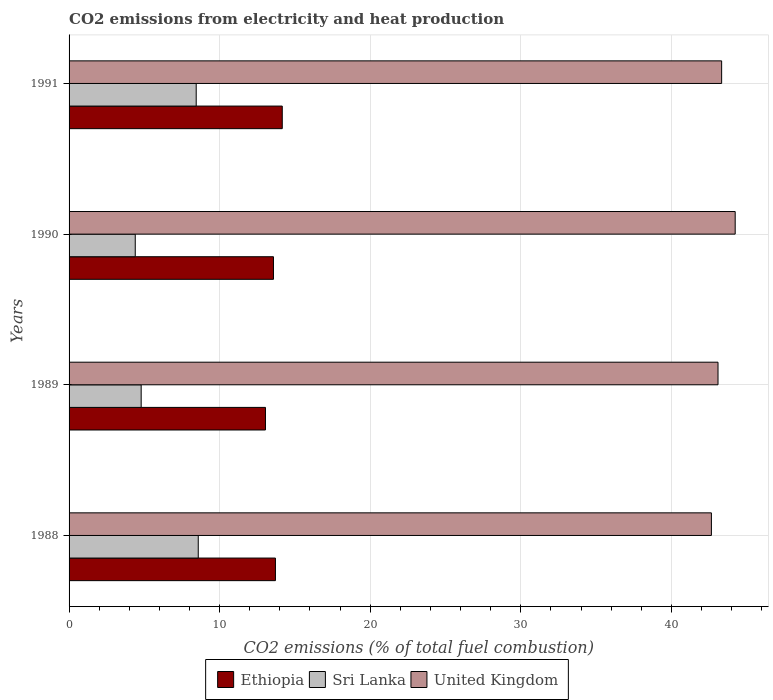How many groups of bars are there?
Offer a terse response. 4. How many bars are there on the 1st tick from the bottom?
Give a very brief answer. 3. In how many cases, is the number of bars for a given year not equal to the number of legend labels?
Ensure brevity in your answer.  0. What is the amount of CO2 emitted in Sri Lanka in 1990?
Your response must be concise. 4.4. Across all years, what is the maximum amount of CO2 emitted in Sri Lanka?
Your response must be concise. 8.58. Across all years, what is the minimum amount of CO2 emitted in United Kingdom?
Keep it short and to the point. 42.66. In which year was the amount of CO2 emitted in Sri Lanka maximum?
Your response must be concise. 1988. What is the total amount of CO2 emitted in United Kingdom in the graph?
Provide a short and direct response. 173.34. What is the difference between the amount of CO2 emitted in Sri Lanka in 1989 and that in 1991?
Make the answer very short. -3.65. What is the difference between the amount of CO2 emitted in Sri Lanka in 1991 and the amount of CO2 emitted in United Kingdom in 1988?
Make the answer very short. -34.22. What is the average amount of CO2 emitted in United Kingdom per year?
Offer a terse response. 43.34. In the year 1991, what is the difference between the amount of CO2 emitted in Ethiopia and amount of CO2 emitted in United Kingdom?
Make the answer very short. -29.18. What is the ratio of the amount of CO2 emitted in United Kingdom in 1988 to that in 1991?
Provide a succinct answer. 0.98. Is the difference between the amount of CO2 emitted in Ethiopia in 1988 and 1989 greater than the difference between the amount of CO2 emitted in United Kingdom in 1988 and 1989?
Your answer should be compact. Yes. What is the difference between the highest and the second highest amount of CO2 emitted in Sri Lanka?
Give a very brief answer. 0.14. What is the difference between the highest and the lowest amount of CO2 emitted in Sri Lanka?
Your answer should be compact. 4.18. Is the sum of the amount of CO2 emitted in United Kingdom in 1989 and 1991 greater than the maximum amount of CO2 emitted in Sri Lanka across all years?
Provide a short and direct response. Yes. What does the 2nd bar from the top in 1988 represents?
Ensure brevity in your answer.  Sri Lanka. What does the 3rd bar from the bottom in 1989 represents?
Offer a very short reply. United Kingdom. Is it the case that in every year, the sum of the amount of CO2 emitted in United Kingdom and amount of CO2 emitted in Sri Lanka is greater than the amount of CO2 emitted in Ethiopia?
Ensure brevity in your answer.  Yes. Are all the bars in the graph horizontal?
Provide a succinct answer. Yes. How many years are there in the graph?
Offer a very short reply. 4. Does the graph contain any zero values?
Offer a terse response. No. Where does the legend appear in the graph?
Provide a succinct answer. Bottom center. How are the legend labels stacked?
Offer a very short reply. Horizontal. What is the title of the graph?
Provide a short and direct response. CO2 emissions from electricity and heat production. Does "Brunei Darussalam" appear as one of the legend labels in the graph?
Provide a short and direct response. No. What is the label or title of the X-axis?
Provide a succinct answer. CO2 emissions (% of total fuel combustion). What is the label or title of the Y-axis?
Your answer should be compact. Years. What is the CO2 emissions (% of total fuel combustion) in Ethiopia in 1988?
Make the answer very short. 13.71. What is the CO2 emissions (% of total fuel combustion) of Sri Lanka in 1988?
Provide a succinct answer. 8.58. What is the CO2 emissions (% of total fuel combustion) in United Kingdom in 1988?
Offer a terse response. 42.66. What is the CO2 emissions (% of total fuel combustion) in Ethiopia in 1989?
Your answer should be very brief. 13.04. What is the CO2 emissions (% of total fuel combustion) in Sri Lanka in 1989?
Make the answer very short. 4.79. What is the CO2 emissions (% of total fuel combustion) in United Kingdom in 1989?
Your response must be concise. 43.1. What is the CO2 emissions (% of total fuel combustion) of Ethiopia in 1990?
Make the answer very short. 13.57. What is the CO2 emissions (% of total fuel combustion) of Sri Lanka in 1990?
Your answer should be compact. 4.4. What is the CO2 emissions (% of total fuel combustion) in United Kingdom in 1990?
Ensure brevity in your answer.  44.24. What is the CO2 emissions (% of total fuel combustion) in Ethiopia in 1991?
Your response must be concise. 14.16. What is the CO2 emissions (% of total fuel combustion) in Sri Lanka in 1991?
Ensure brevity in your answer.  8.44. What is the CO2 emissions (% of total fuel combustion) of United Kingdom in 1991?
Offer a very short reply. 43.34. Across all years, what is the maximum CO2 emissions (% of total fuel combustion) of Ethiopia?
Make the answer very short. 14.16. Across all years, what is the maximum CO2 emissions (% of total fuel combustion) in Sri Lanka?
Keep it short and to the point. 8.58. Across all years, what is the maximum CO2 emissions (% of total fuel combustion) in United Kingdom?
Your response must be concise. 44.24. Across all years, what is the minimum CO2 emissions (% of total fuel combustion) in Ethiopia?
Ensure brevity in your answer.  13.04. Across all years, what is the minimum CO2 emissions (% of total fuel combustion) of Sri Lanka?
Ensure brevity in your answer.  4.4. Across all years, what is the minimum CO2 emissions (% of total fuel combustion) of United Kingdom?
Your response must be concise. 42.66. What is the total CO2 emissions (% of total fuel combustion) in Ethiopia in the graph?
Offer a terse response. 54.48. What is the total CO2 emissions (% of total fuel combustion) in Sri Lanka in the graph?
Give a very brief answer. 26.21. What is the total CO2 emissions (% of total fuel combustion) of United Kingdom in the graph?
Make the answer very short. 173.34. What is the difference between the CO2 emissions (% of total fuel combustion) of Ethiopia in 1988 and that in 1989?
Ensure brevity in your answer.  0.66. What is the difference between the CO2 emissions (% of total fuel combustion) of Sri Lanka in 1988 and that in 1989?
Provide a short and direct response. 3.79. What is the difference between the CO2 emissions (% of total fuel combustion) in United Kingdom in 1988 and that in 1989?
Offer a terse response. -0.44. What is the difference between the CO2 emissions (% of total fuel combustion) in Ethiopia in 1988 and that in 1990?
Keep it short and to the point. 0.13. What is the difference between the CO2 emissions (% of total fuel combustion) of Sri Lanka in 1988 and that in 1990?
Your answer should be very brief. 4.18. What is the difference between the CO2 emissions (% of total fuel combustion) of United Kingdom in 1988 and that in 1990?
Your response must be concise. -1.58. What is the difference between the CO2 emissions (% of total fuel combustion) in Ethiopia in 1988 and that in 1991?
Your response must be concise. -0.45. What is the difference between the CO2 emissions (% of total fuel combustion) of Sri Lanka in 1988 and that in 1991?
Give a very brief answer. 0.14. What is the difference between the CO2 emissions (% of total fuel combustion) in United Kingdom in 1988 and that in 1991?
Your answer should be compact. -0.68. What is the difference between the CO2 emissions (% of total fuel combustion) in Ethiopia in 1989 and that in 1990?
Offer a very short reply. -0.53. What is the difference between the CO2 emissions (% of total fuel combustion) of Sri Lanka in 1989 and that in 1990?
Give a very brief answer. 0.39. What is the difference between the CO2 emissions (% of total fuel combustion) of United Kingdom in 1989 and that in 1990?
Offer a very short reply. -1.14. What is the difference between the CO2 emissions (% of total fuel combustion) in Ethiopia in 1989 and that in 1991?
Provide a short and direct response. -1.12. What is the difference between the CO2 emissions (% of total fuel combustion) of Sri Lanka in 1989 and that in 1991?
Your response must be concise. -3.65. What is the difference between the CO2 emissions (% of total fuel combustion) of United Kingdom in 1989 and that in 1991?
Offer a very short reply. -0.24. What is the difference between the CO2 emissions (% of total fuel combustion) of Ethiopia in 1990 and that in 1991?
Keep it short and to the point. -0.58. What is the difference between the CO2 emissions (% of total fuel combustion) in Sri Lanka in 1990 and that in 1991?
Your response must be concise. -4.05. What is the difference between the CO2 emissions (% of total fuel combustion) of Ethiopia in 1988 and the CO2 emissions (% of total fuel combustion) of Sri Lanka in 1989?
Your response must be concise. 8.92. What is the difference between the CO2 emissions (% of total fuel combustion) of Ethiopia in 1988 and the CO2 emissions (% of total fuel combustion) of United Kingdom in 1989?
Provide a short and direct response. -29.39. What is the difference between the CO2 emissions (% of total fuel combustion) in Sri Lanka in 1988 and the CO2 emissions (% of total fuel combustion) in United Kingdom in 1989?
Your response must be concise. -34.52. What is the difference between the CO2 emissions (% of total fuel combustion) in Ethiopia in 1988 and the CO2 emissions (% of total fuel combustion) in Sri Lanka in 1990?
Ensure brevity in your answer.  9.31. What is the difference between the CO2 emissions (% of total fuel combustion) in Ethiopia in 1988 and the CO2 emissions (% of total fuel combustion) in United Kingdom in 1990?
Keep it short and to the point. -30.53. What is the difference between the CO2 emissions (% of total fuel combustion) in Sri Lanka in 1988 and the CO2 emissions (% of total fuel combustion) in United Kingdom in 1990?
Offer a very short reply. -35.66. What is the difference between the CO2 emissions (% of total fuel combustion) in Ethiopia in 1988 and the CO2 emissions (% of total fuel combustion) in Sri Lanka in 1991?
Keep it short and to the point. 5.26. What is the difference between the CO2 emissions (% of total fuel combustion) in Ethiopia in 1988 and the CO2 emissions (% of total fuel combustion) in United Kingdom in 1991?
Your response must be concise. -29.63. What is the difference between the CO2 emissions (% of total fuel combustion) in Sri Lanka in 1988 and the CO2 emissions (% of total fuel combustion) in United Kingdom in 1991?
Offer a very short reply. -34.76. What is the difference between the CO2 emissions (% of total fuel combustion) in Ethiopia in 1989 and the CO2 emissions (% of total fuel combustion) in Sri Lanka in 1990?
Provide a succinct answer. 8.65. What is the difference between the CO2 emissions (% of total fuel combustion) in Ethiopia in 1989 and the CO2 emissions (% of total fuel combustion) in United Kingdom in 1990?
Your answer should be compact. -31.2. What is the difference between the CO2 emissions (% of total fuel combustion) in Sri Lanka in 1989 and the CO2 emissions (% of total fuel combustion) in United Kingdom in 1990?
Make the answer very short. -39.45. What is the difference between the CO2 emissions (% of total fuel combustion) in Ethiopia in 1989 and the CO2 emissions (% of total fuel combustion) in Sri Lanka in 1991?
Offer a very short reply. 4.6. What is the difference between the CO2 emissions (% of total fuel combustion) of Ethiopia in 1989 and the CO2 emissions (% of total fuel combustion) of United Kingdom in 1991?
Your answer should be compact. -30.3. What is the difference between the CO2 emissions (% of total fuel combustion) in Sri Lanka in 1989 and the CO2 emissions (% of total fuel combustion) in United Kingdom in 1991?
Offer a terse response. -38.55. What is the difference between the CO2 emissions (% of total fuel combustion) in Ethiopia in 1990 and the CO2 emissions (% of total fuel combustion) in Sri Lanka in 1991?
Provide a short and direct response. 5.13. What is the difference between the CO2 emissions (% of total fuel combustion) of Ethiopia in 1990 and the CO2 emissions (% of total fuel combustion) of United Kingdom in 1991?
Your response must be concise. -29.77. What is the difference between the CO2 emissions (% of total fuel combustion) of Sri Lanka in 1990 and the CO2 emissions (% of total fuel combustion) of United Kingdom in 1991?
Provide a short and direct response. -38.94. What is the average CO2 emissions (% of total fuel combustion) of Ethiopia per year?
Provide a succinct answer. 13.62. What is the average CO2 emissions (% of total fuel combustion) in Sri Lanka per year?
Provide a short and direct response. 6.55. What is the average CO2 emissions (% of total fuel combustion) of United Kingdom per year?
Your answer should be very brief. 43.34. In the year 1988, what is the difference between the CO2 emissions (% of total fuel combustion) in Ethiopia and CO2 emissions (% of total fuel combustion) in Sri Lanka?
Provide a short and direct response. 5.13. In the year 1988, what is the difference between the CO2 emissions (% of total fuel combustion) in Ethiopia and CO2 emissions (% of total fuel combustion) in United Kingdom?
Make the answer very short. -28.96. In the year 1988, what is the difference between the CO2 emissions (% of total fuel combustion) in Sri Lanka and CO2 emissions (% of total fuel combustion) in United Kingdom?
Your response must be concise. -34.08. In the year 1989, what is the difference between the CO2 emissions (% of total fuel combustion) in Ethiopia and CO2 emissions (% of total fuel combustion) in Sri Lanka?
Your answer should be very brief. 8.25. In the year 1989, what is the difference between the CO2 emissions (% of total fuel combustion) in Ethiopia and CO2 emissions (% of total fuel combustion) in United Kingdom?
Keep it short and to the point. -30.06. In the year 1989, what is the difference between the CO2 emissions (% of total fuel combustion) in Sri Lanka and CO2 emissions (% of total fuel combustion) in United Kingdom?
Offer a very short reply. -38.31. In the year 1990, what is the difference between the CO2 emissions (% of total fuel combustion) of Ethiopia and CO2 emissions (% of total fuel combustion) of Sri Lanka?
Offer a terse response. 9.18. In the year 1990, what is the difference between the CO2 emissions (% of total fuel combustion) of Ethiopia and CO2 emissions (% of total fuel combustion) of United Kingdom?
Offer a terse response. -30.67. In the year 1990, what is the difference between the CO2 emissions (% of total fuel combustion) of Sri Lanka and CO2 emissions (% of total fuel combustion) of United Kingdom?
Ensure brevity in your answer.  -39.84. In the year 1991, what is the difference between the CO2 emissions (% of total fuel combustion) in Ethiopia and CO2 emissions (% of total fuel combustion) in Sri Lanka?
Ensure brevity in your answer.  5.72. In the year 1991, what is the difference between the CO2 emissions (% of total fuel combustion) of Ethiopia and CO2 emissions (% of total fuel combustion) of United Kingdom?
Your response must be concise. -29.18. In the year 1991, what is the difference between the CO2 emissions (% of total fuel combustion) in Sri Lanka and CO2 emissions (% of total fuel combustion) in United Kingdom?
Make the answer very short. -34.9. What is the ratio of the CO2 emissions (% of total fuel combustion) of Ethiopia in 1988 to that in 1989?
Keep it short and to the point. 1.05. What is the ratio of the CO2 emissions (% of total fuel combustion) in Sri Lanka in 1988 to that in 1989?
Ensure brevity in your answer.  1.79. What is the ratio of the CO2 emissions (% of total fuel combustion) of United Kingdom in 1988 to that in 1989?
Provide a succinct answer. 0.99. What is the ratio of the CO2 emissions (% of total fuel combustion) of Ethiopia in 1988 to that in 1990?
Offer a terse response. 1.01. What is the ratio of the CO2 emissions (% of total fuel combustion) of Sri Lanka in 1988 to that in 1990?
Give a very brief answer. 1.95. What is the ratio of the CO2 emissions (% of total fuel combustion) of United Kingdom in 1988 to that in 1990?
Keep it short and to the point. 0.96. What is the ratio of the CO2 emissions (% of total fuel combustion) of Ethiopia in 1988 to that in 1991?
Your response must be concise. 0.97. What is the ratio of the CO2 emissions (% of total fuel combustion) of Sri Lanka in 1988 to that in 1991?
Your answer should be very brief. 1.02. What is the ratio of the CO2 emissions (% of total fuel combustion) in United Kingdom in 1988 to that in 1991?
Provide a succinct answer. 0.98. What is the ratio of the CO2 emissions (% of total fuel combustion) in Ethiopia in 1989 to that in 1990?
Your answer should be very brief. 0.96. What is the ratio of the CO2 emissions (% of total fuel combustion) of Sri Lanka in 1989 to that in 1990?
Your answer should be compact. 1.09. What is the ratio of the CO2 emissions (% of total fuel combustion) in United Kingdom in 1989 to that in 1990?
Your response must be concise. 0.97. What is the ratio of the CO2 emissions (% of total fuel combustion) of Ethiopia in 1989 to that in 1991?
Your answer should be compact. 0.92. What is the ratio of the CO2 emissions (% of total fuel combustion) in Sri Lanka in 1989 to that in 1991?
Ensure brevity in your answer.  0.57. What is the ratio of the CO2 emissions (% of total fuel combustion) of Ethiopia in 1990 to that in 1991?
Provide a succinct answer. 0.96. What is the ratio of the CO2 emissions (% of total fuel combustion) of Sri Lanka in 1990 to that in 1991?
Ensure brevity in your answer.  0.52. What is the ratio of the CO2 emissions (% of total fuel combustion) of United Kingdom in 1990 to that in 1991?
Provide a short and direct response. 1.02. What is the difference between the highest and the second highest CO2 emissions (% of total fuel combustion) in Ethiopia?
Make the answer very short. 0.45. What is the difference between the highest and the second highest CO2 emissions (% of total fuel combustion) of Sri Lanka?
Make the answer very short. 0.14. What is the difference between the highest and the lowest CO2 emissions (% of total fuel combustion) in Ethiopia?
Keep it short and to the point. 1.12. What is the difference between the highest and the lowest CO2 emissions (% of total fuel combustion) of Sri Lanka?
Ensure brevity in your answer.  4.18. What is the difference between the highest and the lowest CO2 emissions (% of total fuel combustion) in United Kingdom?
Keep it short and to the point. 1.58. 